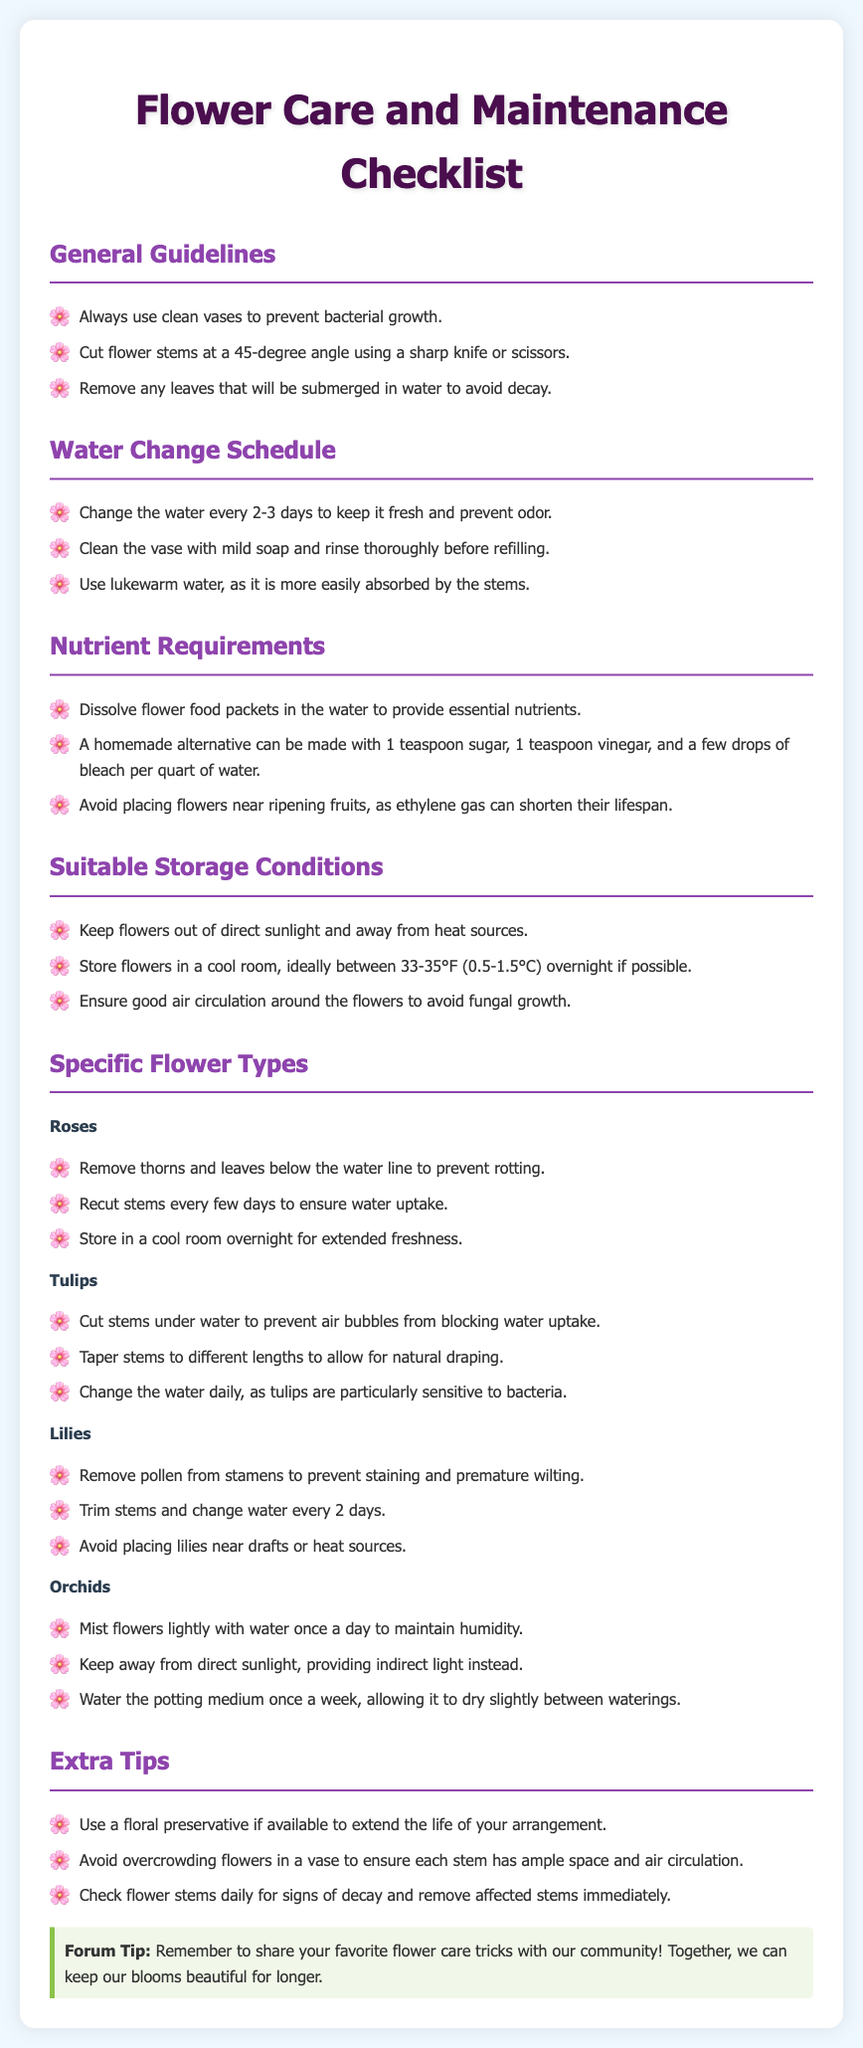What is the ideal water change frequency for flowers? The document states that water should be changed every 2-3 days to keep it fresh and prevent odor.
Answer: 2-3 days What temperature range is recommended for storing flowers overnight? According to the document, flowers should be stored ideally between 33-35°F (0.5-1.5°C) overnight.
Answer: 33-35°F Which flower type should have its stems cut under water? The document specifically mentions that tulip stems should be cut under water to prevent air bubbles.
Answer: Tulips What should be removed from lilies to prevent staining? The checklist indicates that pollen from stamens should be removed from lilies to prevent staining.
Answer: Pollen What homemade ingredient is suggested for flower food? The document suggests using sugar as part of a homemade alternative for flower food.
Answer: Sugar How often should orchids be misted to maintain humidity? The checklist states that orchids should be misted lightly with water once a day.
Answer: Once a day What is a key tip regarding flower arrangement in vases? The document emphasizes not to overcrowd flowers in a vase to ensure each stem has space and air circulation.
Answer: Avoid overcrowding What is the purpose of a floral preservative? The document mentions using a floral preservative to extend the life of your arrangement.
Answer: Extend life 